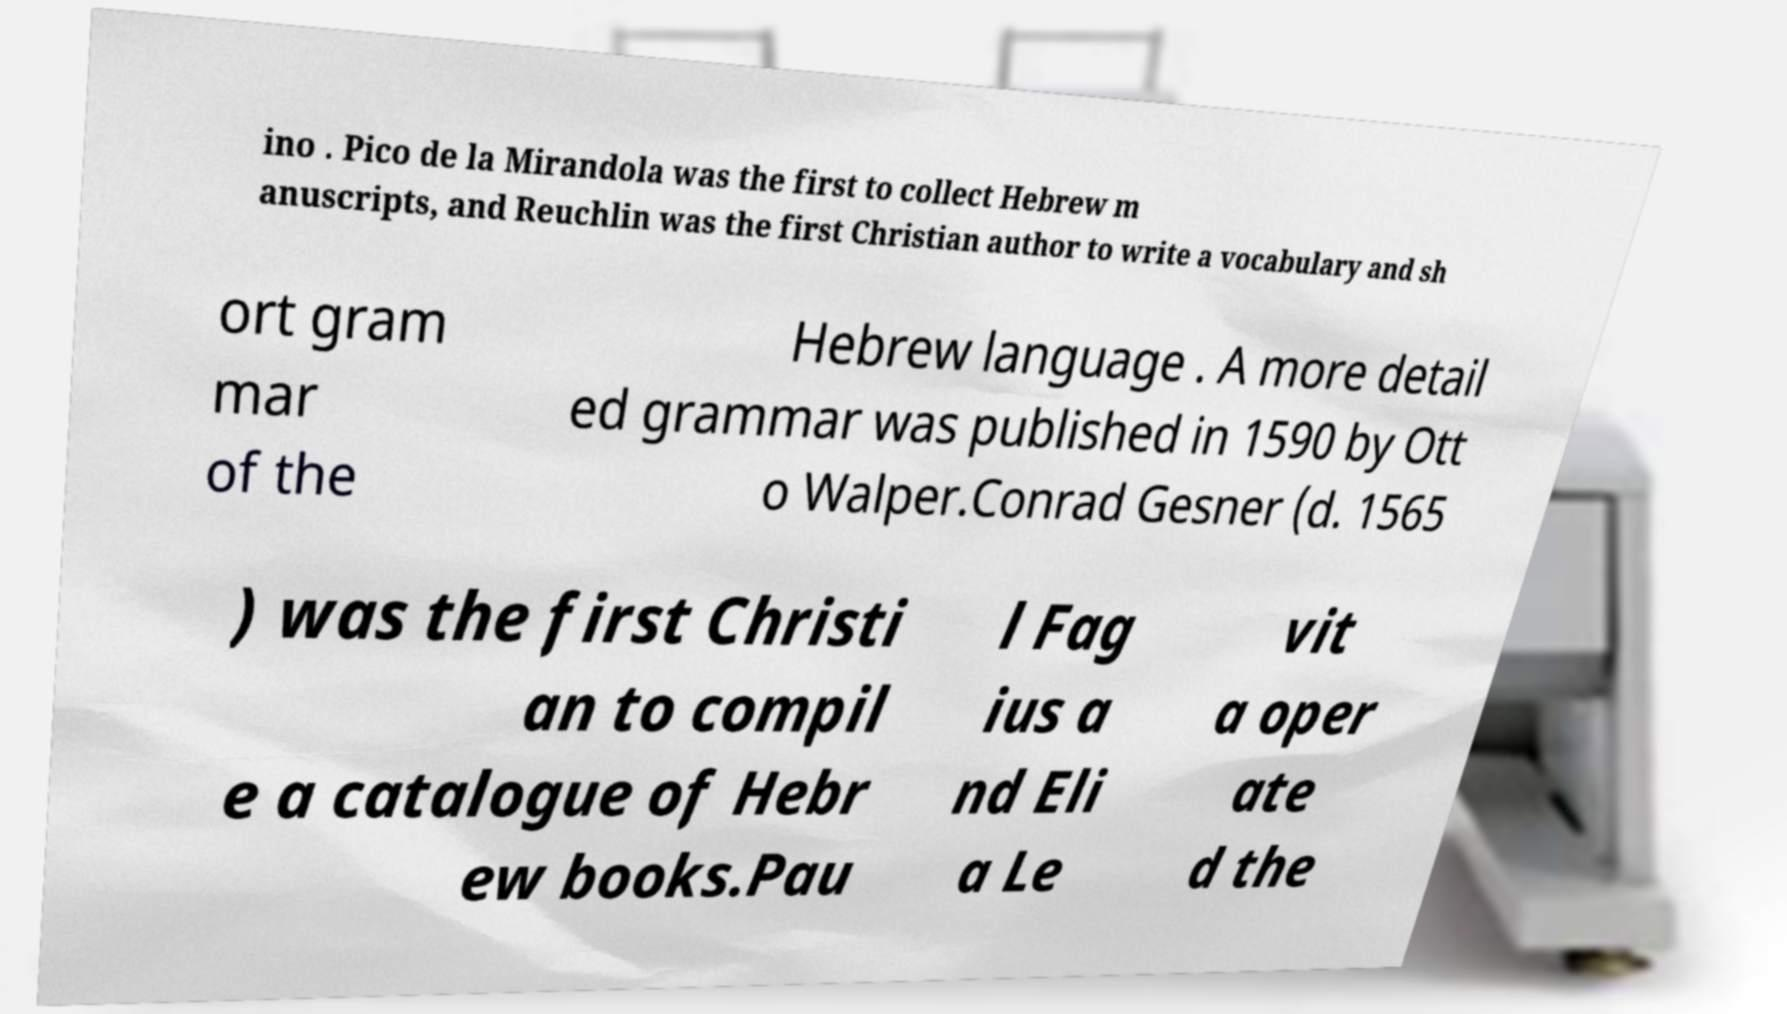For documentation purposes, I need the text within this image transcribed. Could you provide that? ino . Pico de la Mirandola was the first to collect Hebrew m anuscripts, and Reuchlin was the first Christian author to write a vocabulary and sh ort gram mar of the Hebrew language . A more detail ed grammar was published in 1590 by Ott o Walper.Conrad Gesner (d. 1565 ) was the first Christi an to compil e a catalogue of Hebr ew books.Pau l Fag ius a nd Eli a Le vit a oper ate d the 